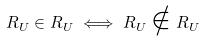<formula> <loc_0><loc_0><loc_500><loc_500>R _ { U } \in R _ { U } \iff R _ { U } \notin R _ { U }</formula> 